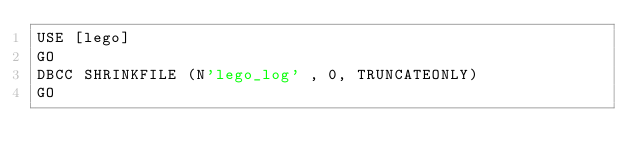Convert code to text. <code><loc_0><loc_0><loc_500><loc_500><_SQL_>USE [lego]
GO
DBCC SHRINKFILE (N'lego_log' , 0, TRUNCATEONLY)
GO</code> 